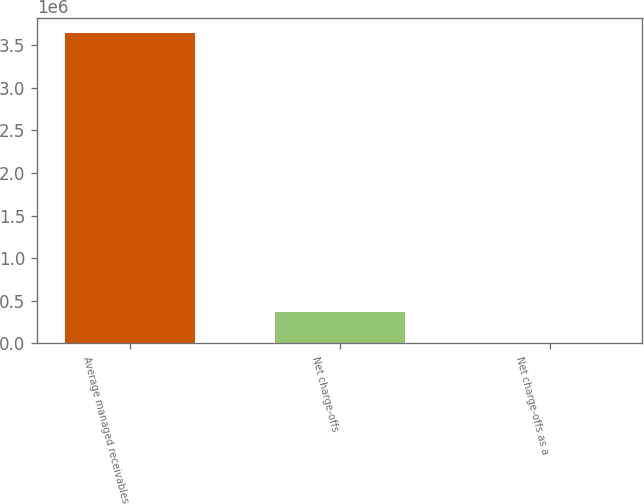Convert chart to OTSL. <chart><loc_0><loc_0><loc_500><loc_500><bar_chart><fcel>Average managed receivables<fcel>Net charge-offs<fcel>Net charge-offs as a<nl><fcel>3.64006e+06<fcel>364010<fcel>5<nl></chart> 